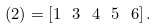Convert formula to latex. <formula><loc_0><loc_0><loc_500><loc_500>( 2 ) = [ 1 \ 3 \ 4 \ 5 \ 6 ] \, .</formula> 